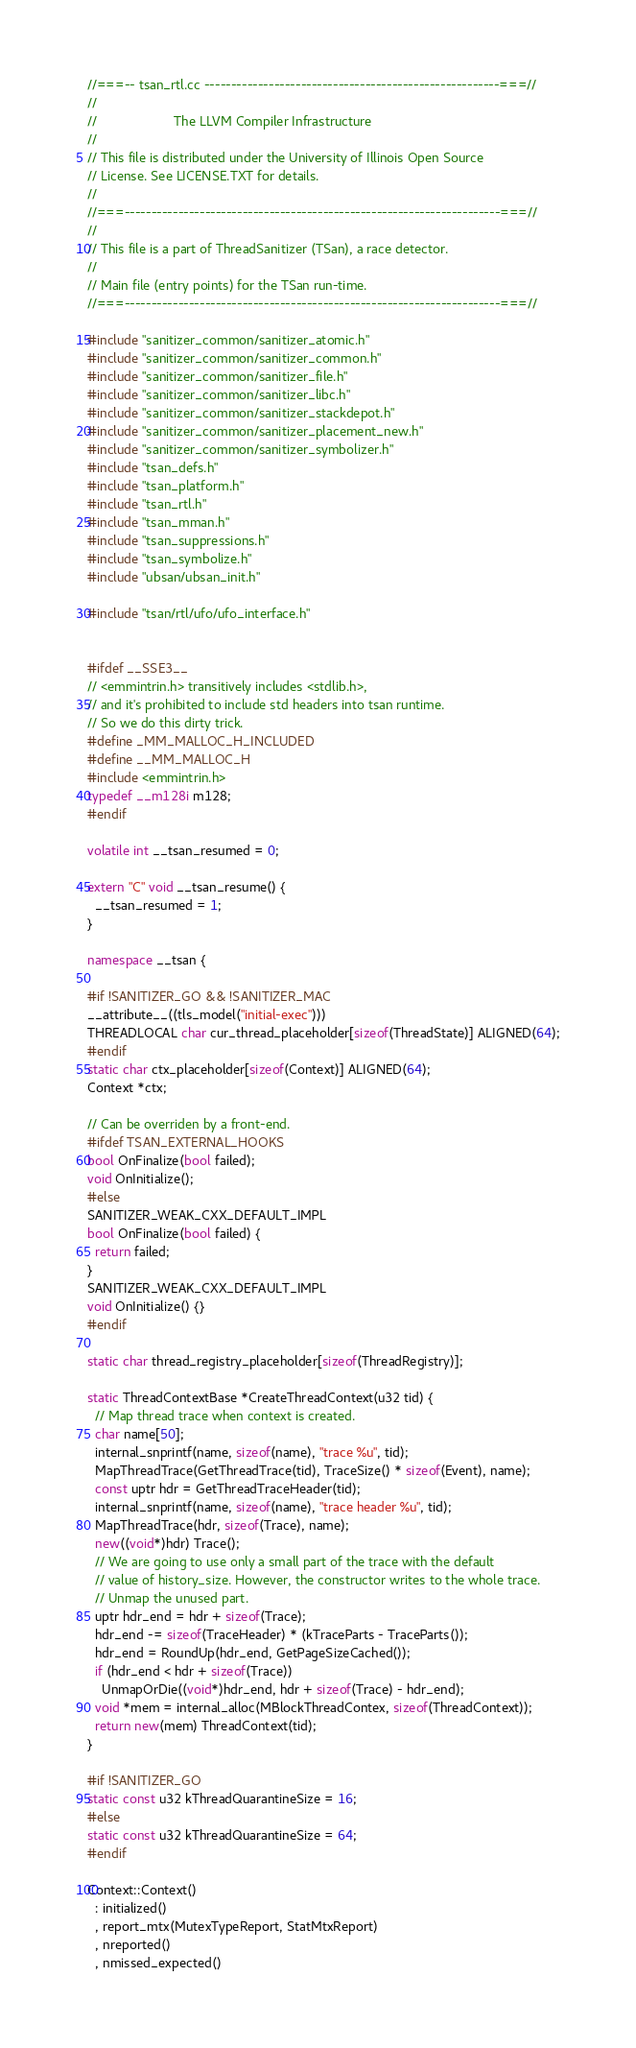<code> <loc_0><loc_0><loc_500><loc_500><_C++_>//===-- tsan_rtl.cc -------------------------------------------------------===//
//
//                     The LLVM Compiler Infrastructure
//
// This file is distributed under the University of Illinois Open Source
// License. See LICENSE.TXT for details.
//
//===----------------------------------------------------------------------===//
//
// This file is a part of ThreadSanitizer (TSan), a race detector.
//
// Main file (entry points) for the TSan run-time.
//===----------------------------------------------------------------------===//

#include "sanitizer_common/sanitizer_atomic.h"
#include "sanitizer_common/sanitizer_common.h"
#include "sanitizer_common/sanitizer_file.h"
#include "sanitizer_common/sanitizer_libc.h"
#include "sanitizer_common/sanitizer_stackdepot.h"
#include "sanitizer_common/sanitizer_placement_new.h"
#include "sanitizer_common/sanitizer_symbolizer.h"
#include "tsan_defs.h"
#include "tsan_platform.h"
#include "tsan_rtl.h"
#include "tsan_mman.h"
#include "tsan_suppressions.h"
#include "tsan_symbolize.h"
#include "ubsan/ubsan_init.h"

#include "tsan/rtl/ufo/ufo_interface.h"


#ifdef __SSE3__
// <emmintrin.h> transitively includes <stdlib.h>,
// and it's prohibited to include std headers into tsan runtime.
// So we do this dirty trick.
#define _MM_MALLOC_H_INCLUDED
#define __MM_MALLOC_H
#include <emmintrin.h>
typedef __m128i m128;
#endif

volatile int __tsan_resumed = 0;

extern "C" void __tsan_resume() {
  __tsan_resumed = 1;
}

namespace __tsan {

#if !SANITIZER_GO && !SANITIZER_MAC
__attribute__((tls_model("initial-exec")))
THREADLOCAL char cur_thread_placeholder[sizeof(ThreadState)] ALIGNED(64);
#endif
static char ctx_placeholder[sizeof(Context)] ALIGNED(64);
Context *ctx;

// Can be overriden by a front-end.
#ifdef TSAN_EXTERNAL_HOOKS
bool OnFinalize(bool failed);
void OnInitialize();
#else
SANITIZER_WEAK_CXX_DEFAULT_IMPL
bool OnFinalize(bool failed) {
  return failed;
}
SANITIZER_WEAK_CXX_DEFAULT_IMPL
void OnInitialize() {}
#endif

static char thread_registry_placeholder[sizeof(ThreadRegistry)];

static ThreadContextBase *CreateThreadContext(u32 tid) {
  // Map thread trace when context is created.
  char name[50];
  internal_snprintf(name, sizeof(name), "trace %u", tid);
  MapThreadTrace(GetThreadTrace(tid), TraceSize() * sizeof(Event), name);
  const uptr hdr = GetThreadTraceHeader(tid);
  internal_snprintf(name, sizeof(name), "trace header %u", tid);
  MapThreadTrace(hdr, sizeof(Trace), name);
  new((void*)hdr) Trace();
  // We are going to use only a small part of the trace with the default
  // value of history_size. However, the constructor writes to the whole trace.
  // Unmap the unused part.
  uptr hdr_end = hdr + sizeof(Trace);
  hdr_end -= sizeof(TraceHeader) * (kTraceParts - TraceParts());
  hdr_end = RoundUp(hdr_end, GetPageSizeCached());
  if (hdr_end < hdr + sizeof(Trace))
    UnmapOrDie((void*)hdr_end, hdr + sizeof(Trace) - hdr_end);
  void *mem = internal_alloc(MBlockThreadContex, sizeof(ThreadContext));
  return new(mem) ThreadContext(tid);
}

#if !SANITIZER_GO
static const u32 kThreadQuarantineSize = 16;
#else
static const u32 kThreadQuarantineSize = 64;
#endif

Context::Context()
  : initialized()
  , report_mtx(MutexTypeReport, StatMtxReport)
  , nreported()
  , nmissed_expected()</code> 